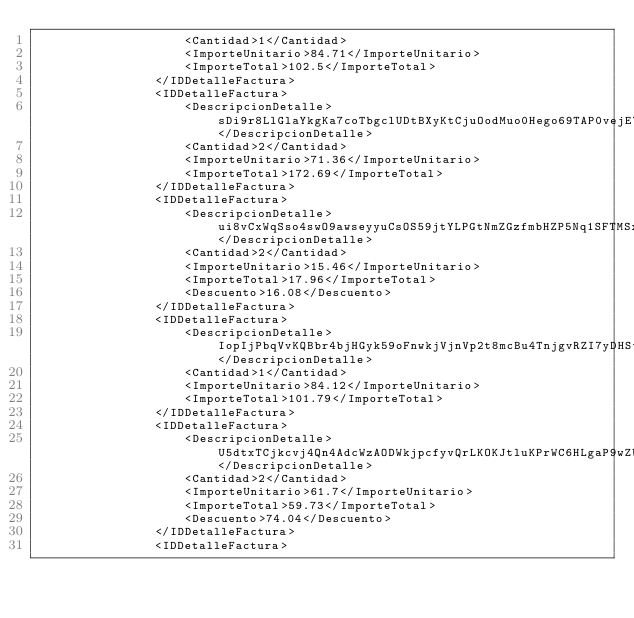Convert code to text. <code><loc_0><loc_0><loc_500><loc_500><_XML_>                    <Cantidad>1</Cantidad>
                    <ImporteUnitario>84.71</ImporteUnitario>
                    <ImporteTotal>102.5</ImporteTotal>
                </IDDetalleFactura>
                <IDDetalleFactura>
                    <DescripcionDetalle>sDi9r8LlGlaYkgKa7coTbgclUDtBXyKtCjuOodMuo0Hego69TAP0vejE7FVcL6WPQ5XJdEpJJWpGYl7wOK19sw3EBLOa1iMoSoGfHEm8mumy70Z773v3B1Blq9i3hmsxlSvfYOHj9uMyFJwf0Sl3wxjTcRxp</DescripcionDetalle>
                    <Cantidad>2</Cantidad>
                    <ImporteUnitario>71.36</ImporteUnitario>
                    <ImporteTotal>172.69</ImporteTotal>
                </IDDetalleFactura>
                <IDDetalleFactura>
                    <DescripcionDetalle>ui8vCxWqSso4swO9awseyyuCsOS59jtYLPGtNmZGzfmbHZP5Nq1SFTMSxyk5uqV2DzKsLIaONuFP3</DescripcionDetalle>
                    <Cantidad>2</Cantidad>
                    <ImporteUnitario>15.46</ImporteUnitario>
                    <ImporteTotal>17.96</ImporteTotal>
                    <Descuento>16.08</Descuento>
                </IDDetalleFactura>
                <IDDetalleFactura>
                    <DescripcionDetalle>IopIjPbqVvKQBbr4bjHGyk59oFnwkjVjnVp2t8mcBu4TnjgvRZI7yDHSt3kkV2kaNlEupppL3wS9wg4tcohvoDS4b3bGX7s9m2xQLDd6SdnSn4PPQLZtgz6NXYRG3YEy6OLoYQ6FoOMvCETtlCf8s</DescripcionDetalle>
                    <Cantidad>1</Cantidad>
                    <ImporteUnitario>84.12</ImporteUnitario>
                    <ImporteTotal>101.79</ImporteTotal>
                </IDDetalleFactura>
                <IDDetalleFactura>
                    <DescripcionDetalle>U5dtxTCjkcvj4Qn4AdcWzAODWkjpcfyvQrLKOKJtluKPrWC6HLgaP9wZW1tm7Q8z1jLmjbEK69avEVX9BysHVJlgFDMogzhHm3u06JoedZRiwenHA</DescripcionDetalle>
                    <Cantidad>2</Cantidad>
                    <ImporteUnitario>61.7</ImporteUnitario>
                    <ImporteTotal>59.73</ImporteTotal>
                    <Descuento>74.04</Descuento>
                </IDDetalleFactura>
                <IDDetalleFactura></code> 